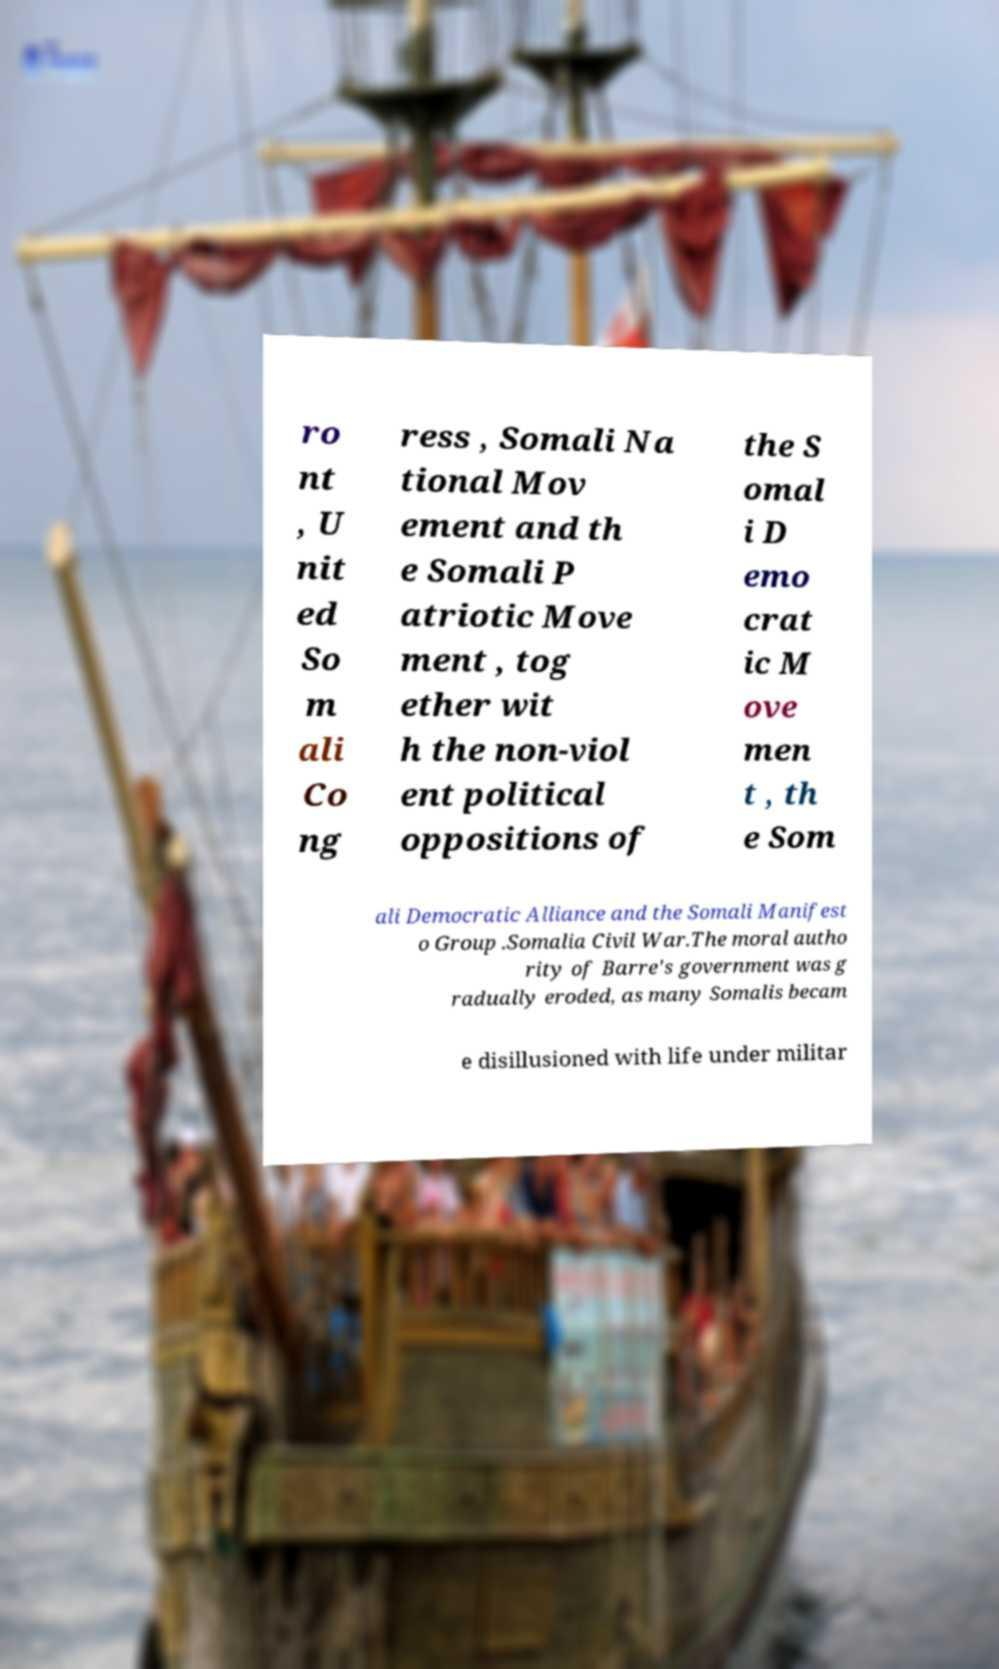For documentation purposes, I need the text within this image transcribed. Could you provide that? ro nt , U nit ed So m ali Co ng ress , Somali Na tional Mov ement and th e Somali P atriotic Move ment , tog ether wit h the non-viol ent political oppositions of the S omal i D emo crat ic M ove men t , th e Som ali Democratic Alliance and the Somali Manifest o Group .Somalia Civil War.The moral autho rity of Barre's government was g radually eroded, as many Somalis becam e disillusioned with life under militar 